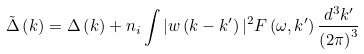Convert formula to latex. <formula><loc_0><loc_0><loc_500><loc_500>\tilde { \Delta } \left ( { k } \right ) = \Delta \left ( { k } \right ) + n _ { i } \int | w \left ( { k } - { k ^ { \prime } } \right ) | ^ { 2 } F \left ( \omega , { k ^ { \prime } } \right ) \frac { d ^ { 3 } k ^ { \prime } } { \left ( 2 \pi \right ) ^ { 3 } }</formula> 